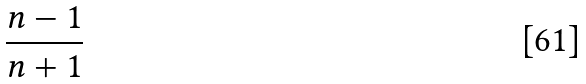Convert formula to latex. <formula><loc_0><loc_0><loc_500><loc_500>\frac { n - 1 } { n + 1 }</formula> 